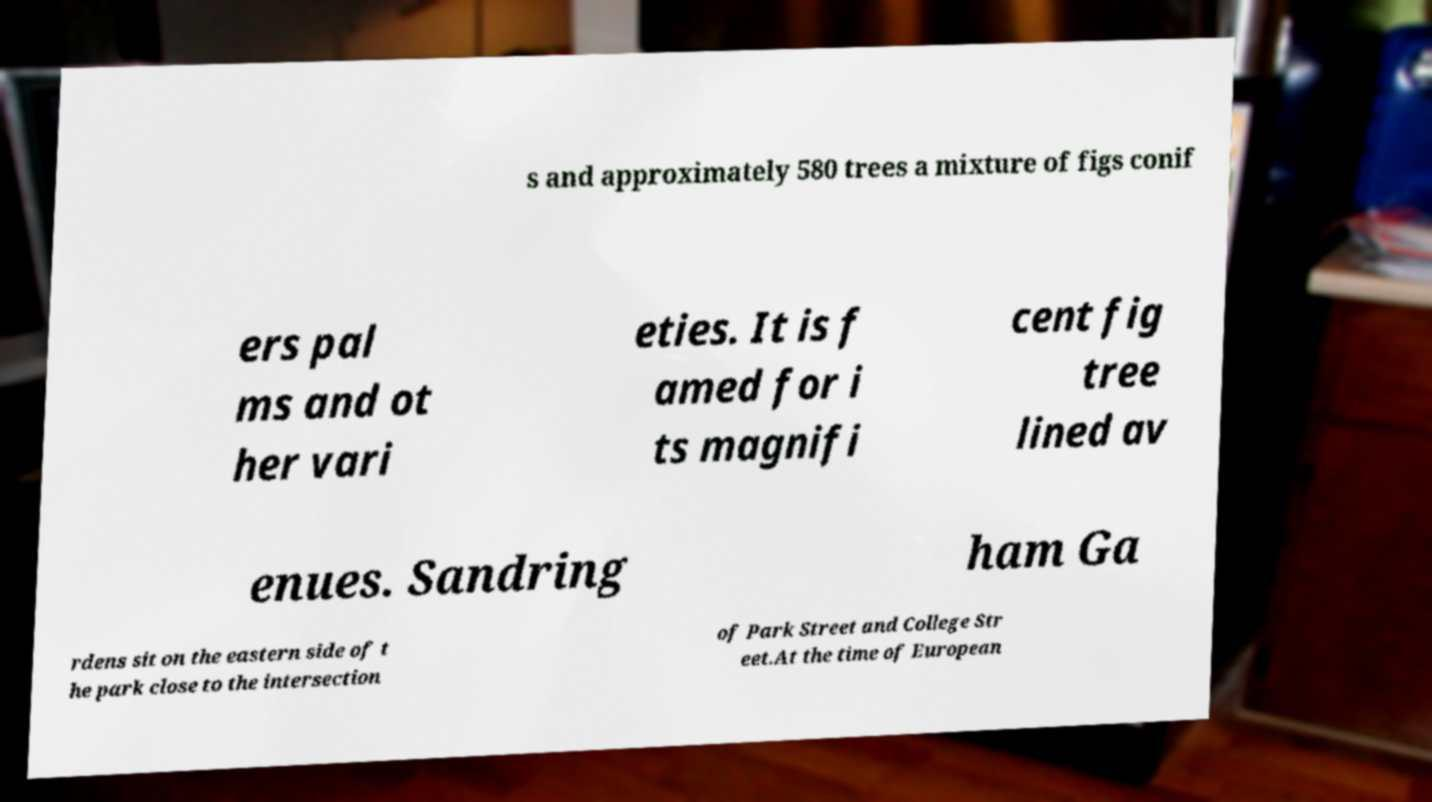I need the written content from this picture converted into text. Can you do that? s and approximately 580 trees a mixture of figs conif ers pal ms and ot her vari eties. It is f amed for i ts magnifi cent fig tree lined av enues. Sandring ham Ga rdens sit on the eastern side of t he park close to the intersection of Park Street and College Str eet.At the time of European 